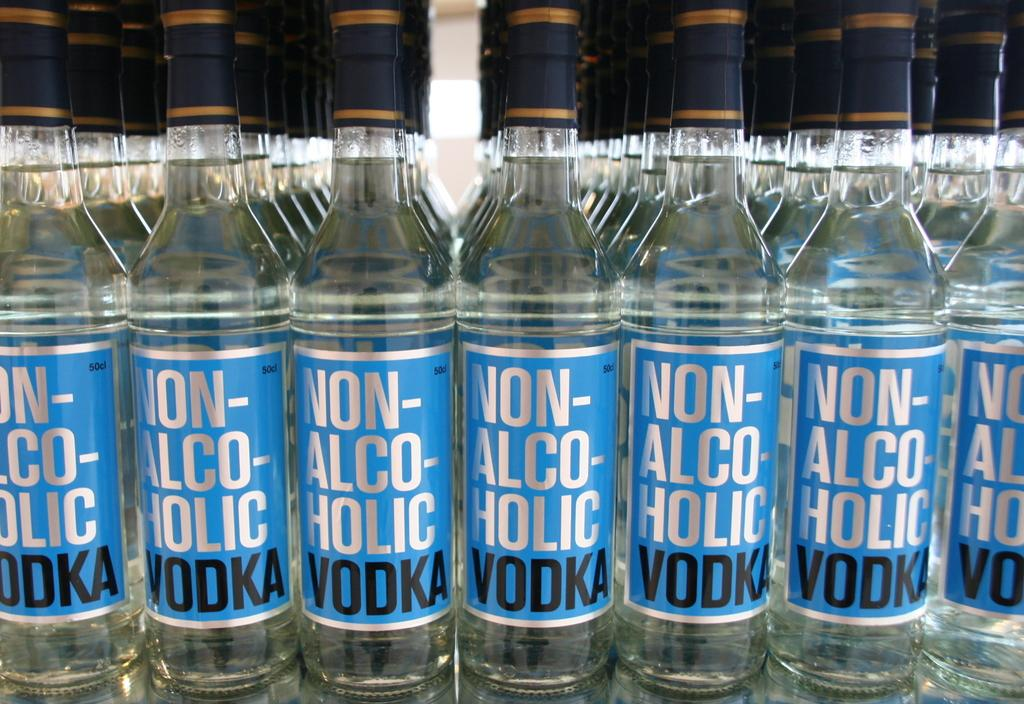<image>
Offer a succinct explanation of the picture presented. rows and rows of non alcoholic vodka next to one another 